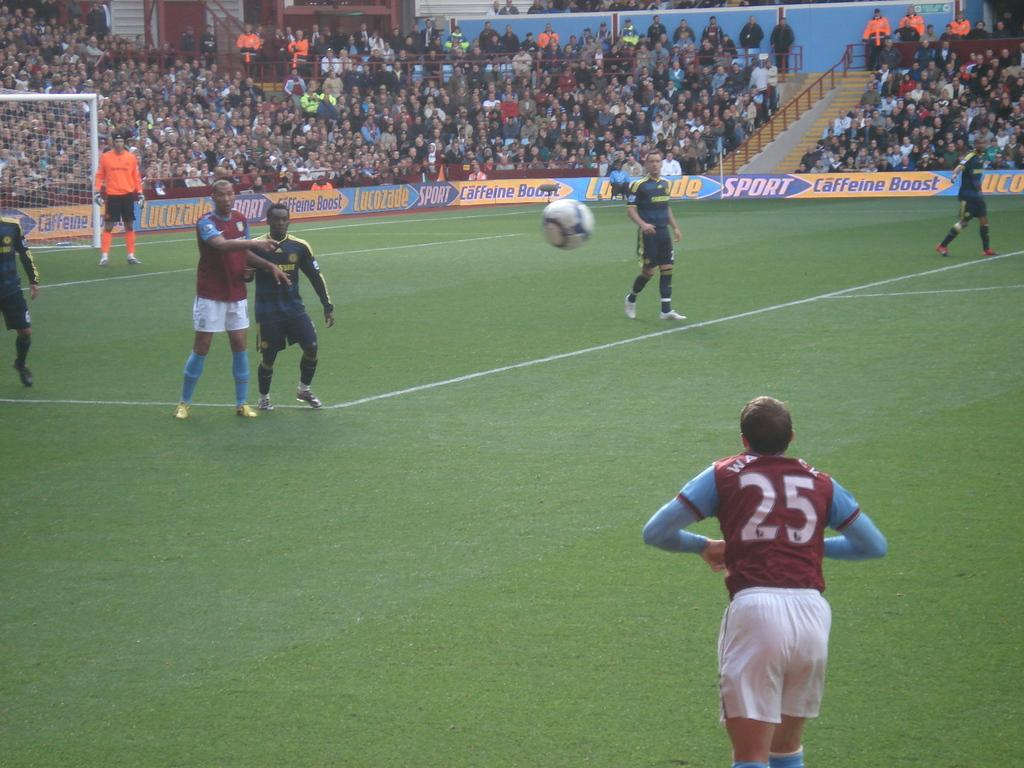Provide a one-sentence caption for the provided image. A soccer player wearing number 25 throws the ball in during a match. 